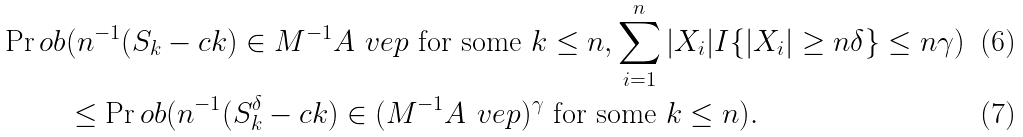Convert formula to latex. <formula><loc_0><loc_0><loc_500><loc_500>\Pr o b & ( n ^ { - 1 } ( S _ { k } - c k ) \in M ^ { - 1 } A ^ { \ } v e p \text { for some } k \leq n , \sum _ { i = 1 } ^ { n } | X _ { i } | I \{ | X _ { i } | \geq n \delta \} \leq n \gamma ) \\ & \leq \Pr o b ( n ^ { - 1 } ( S _ { k } ^ { \delta } - c k ) \in ( M ^ { - 1 } A ^ { \ } v e p ) ^ { \gamma } \text { for some } k \leq n ) .</formula> 